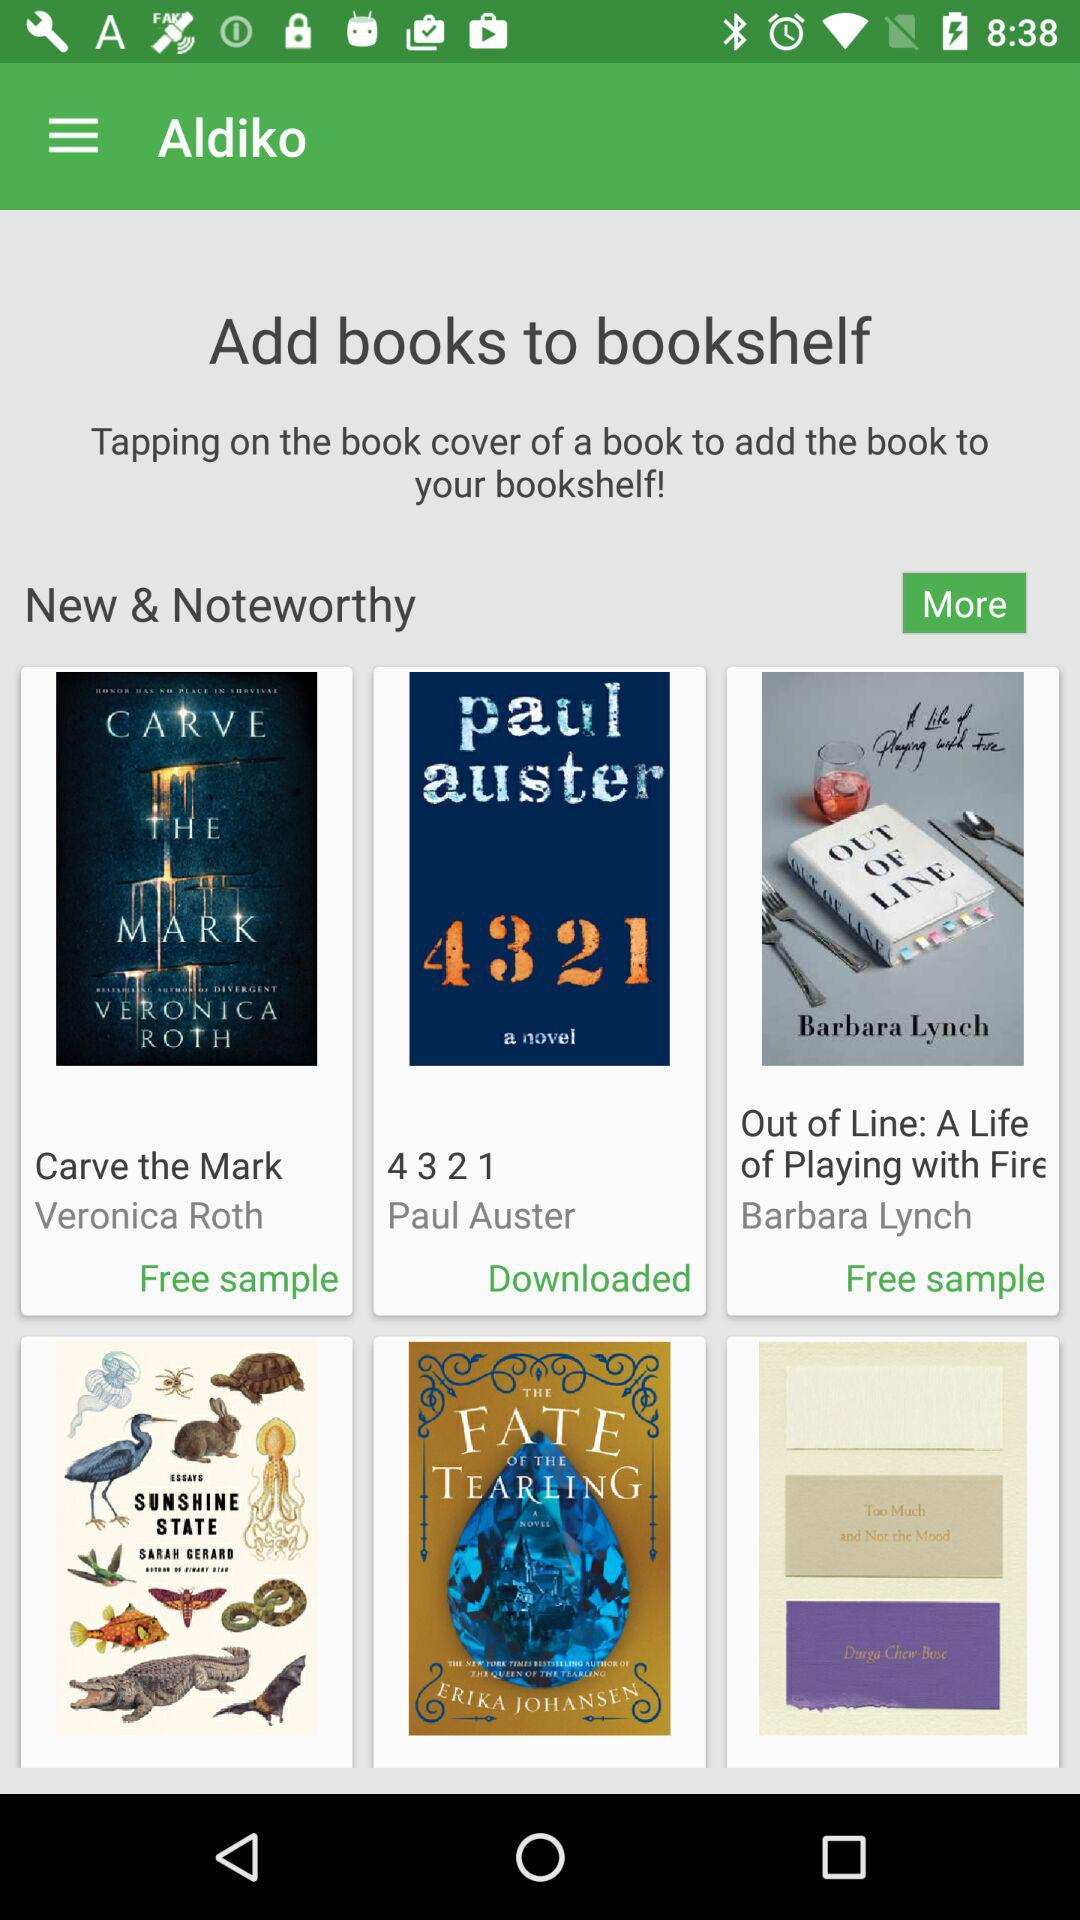What is the application name? The application name is "Aldiko". 